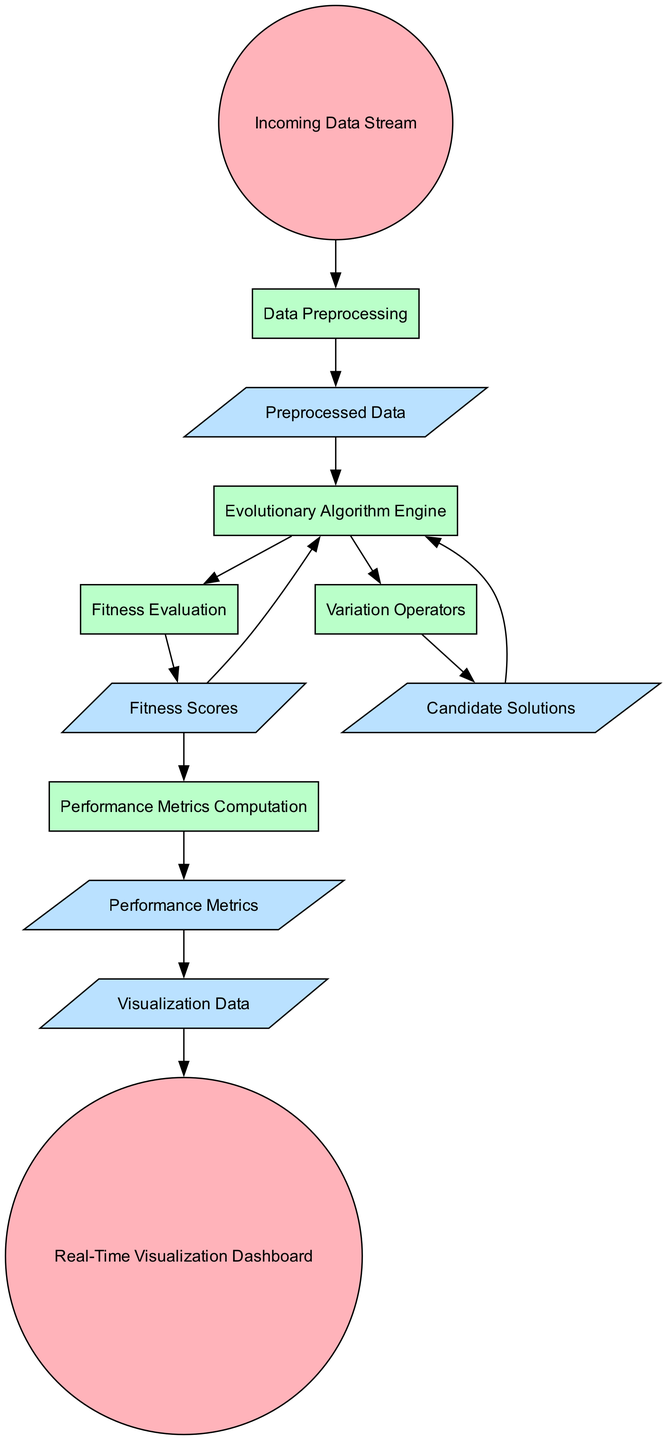What element is the starting point in the diagram? The starting point in the diagram is the "Incoming Data Stream," which is the first external entity that feeds data into the system.
Answer: Incoming Data Stream How many processes are present in the diagram? The diagram contains five processes: "Data Preprocessing," "Evolutionary Algorithm Engine," "Fitness Evaluation," "Variation Operators," and "Performance Metrics Computation."
Answer: Five What type of relationship exists between "Fitness Evaluation" and "Fitness Scores"? The relationship is a one-way data flow where "Fitness Evaluation" outputs "Fitness Scores" after evaluating the candidate solutions.
Answer: Data Flow Which external entity is used to visualize the performance metrics? The external entity used to visualize the performance metrics is the "Real-Time Visualization Dashboard."
Answer: Real-Time Visualization Dashboard What does the "Variation Operators" process produce as output? The "Variation Operators" process produces the "Candidate Solutions" as output after applying genetic operators.
Answer: Candidate Solutions What data flows from "Preprocessed Data" to the "Evolutionary Algorithm Engine"? The data that flows from "Preprocessed Data" to "Evolutionary Algorithm Engine" is the processed data that is ready for use in the evolutionary algorithm.
Answer: Preprocessed Data Explain the flow of data from "Fitness Scores" to "Performance Metrics." "Fitness Scores" are used in the "Performance Metrics Computation" process to calculate various metrics based on ongoing evaluations, which then result in "Performance Metrics."
Answer: Performance Metrics Which data flow connects "Performance Metrics" and the dashboard? The data flow that connects "Performance Metrics" to the dashboard is the "Visualization Data," which is used for real-time monitoring in the "Real-Time Visualization Dashboard."
Answer: Visualization Data How many data flows are present in total in the diagram? There are six data flows, which are: "Preprocessed Data," "Fitness Scores," "Candidate Solutions," "Performance Metrics," and "Visualization Data."
Answer: Six 